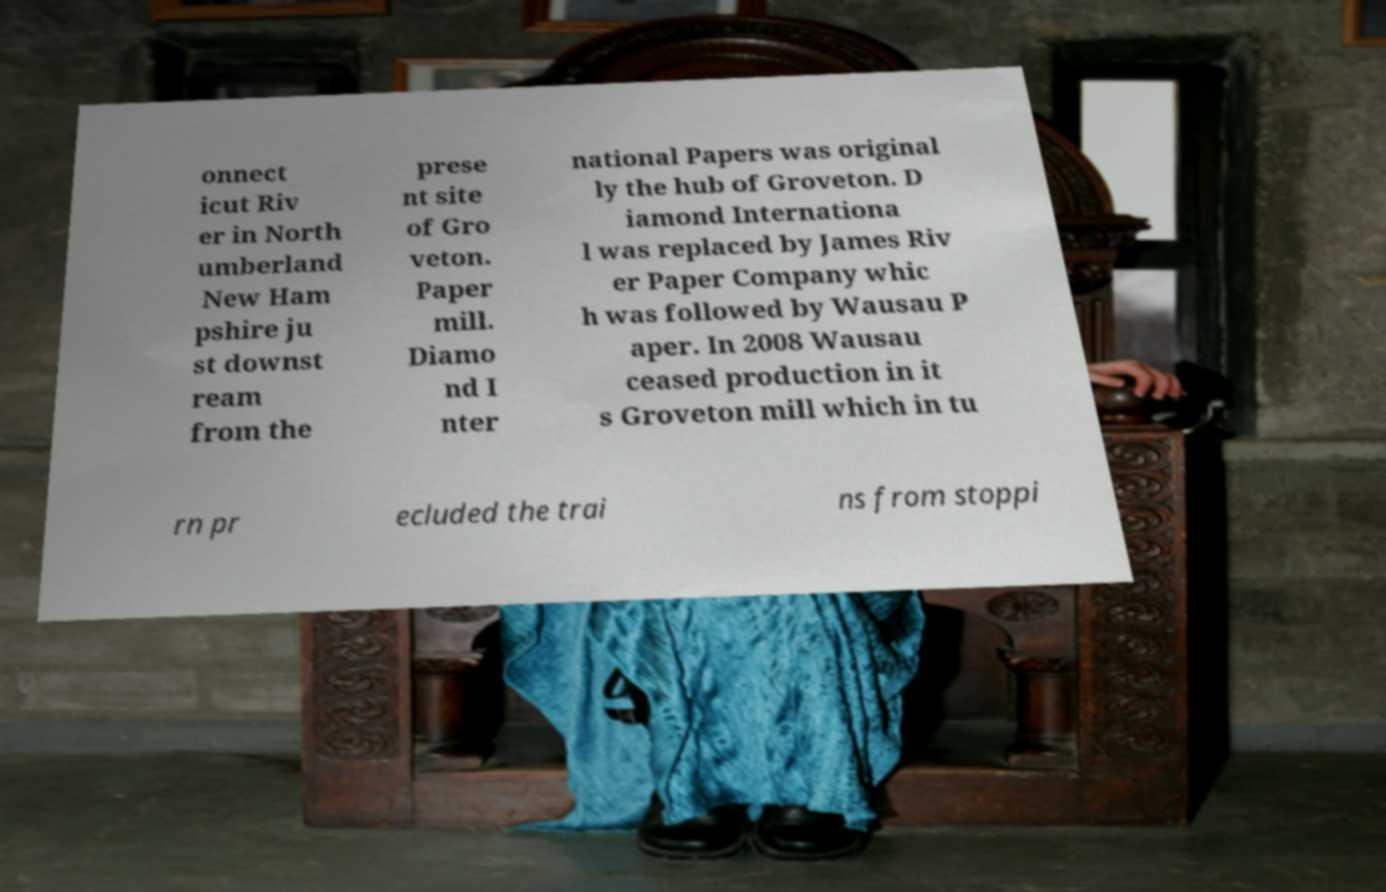Can you read and provide the text displayed in the image?This photo seems to have some interesting text. Can you extract and type it out for me? onnect icut Riv er in North umberland New Ham pshire ju st downst ream from the prese nt site of Gro veton. Paper mill. Diamo nd I nter national Papers was original ly the hub of Groveton. D iamond Internationa l was replaced by James Riv er Paper Company whic h was followed by Wausau P aper. In 2008 Wausau ceased production in it s Groveton mill which in tu rn pr ecluded the trai ns from stoppi 